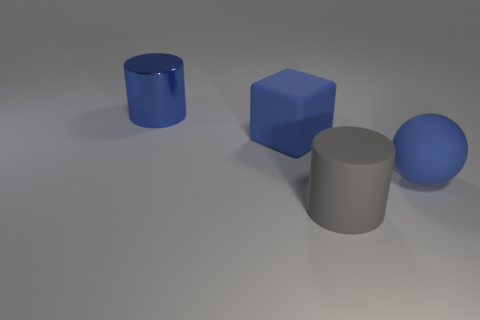Is there any other thing that has the same material as the blue cylinder?
Give a very brief answer. No. There is a big thing that is right of the blue shiny object and to the left of the big gray cylinder; what color is it?
Offer a terse response. Blue. Is there anything else that is the same size as the ball?
Make the answer very short. Yes. Are there more big blue rubber blocks behind the large blue rubber sphere than big blue rubber blocks that are in front of the large blue cylinder?
Make the answer very short. No. There is a matte object left of the gray rubber object; is its size the same as the large blue cylinder?
Give a very brief answer. Yes. There is a large cylinder that is in front of the blue thing that is behind the big cube; how many large rubber cubes are in front of it?
Provide a succinct answer. 0. How big is the blue object that is left of the large blue matte sphere and in front of the big metal object?
Offer a terse response. Large. What number of other objects are there of the same shape as the big blue shiny object?
Your response must be concise. 1. How many big blue matte things are right of the large rubber cube?
Your answer should be very brief. 1. Is the number of metal cylinders that are in front of the blue block less than the number of large gray matte objects that are behind the big blue ball?
Provide a succinct answer. No. 